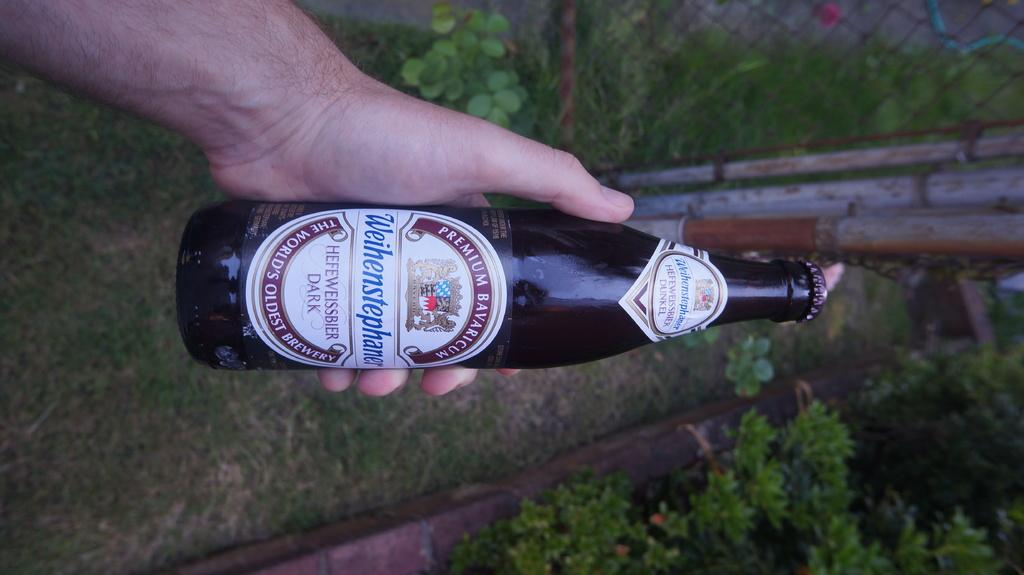<image>
Relay a brief, clear account of the picture shown. a bottle of liquor entitled PREMIUM BAVARICUM Weihenstphaner HEFEWEISSBIER DARK THE WORLD'S OLDEST BREWARY. 